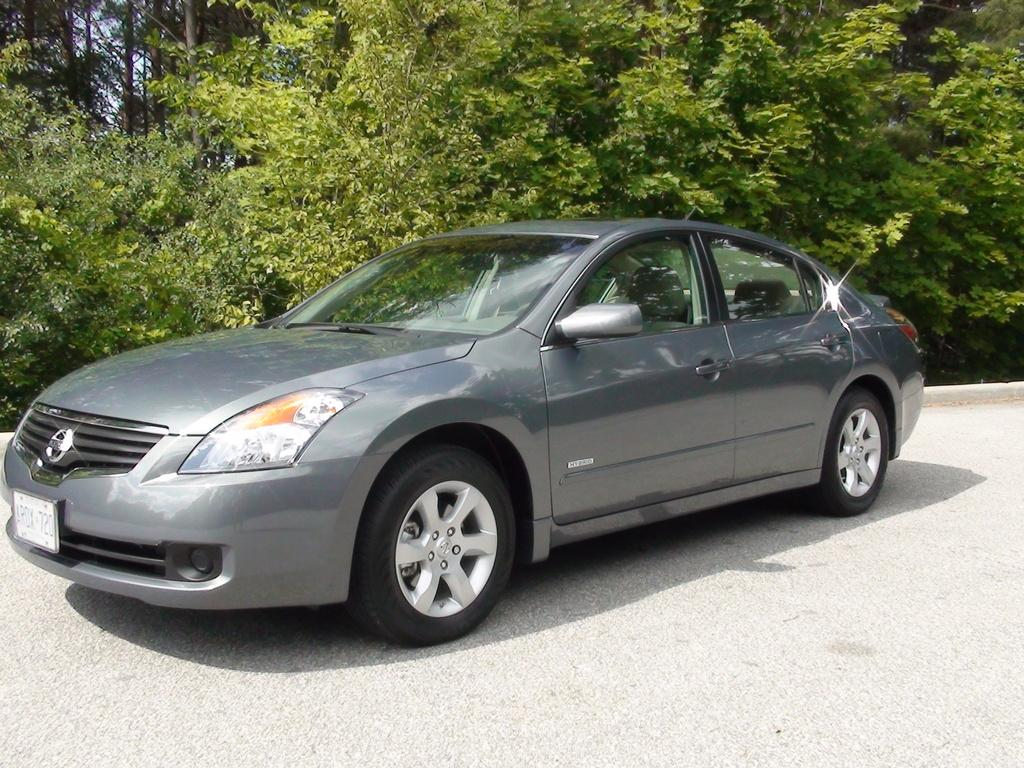<image>
Describe the image concisely. A grey hybrid automobile with the license plate number AROX 720. 